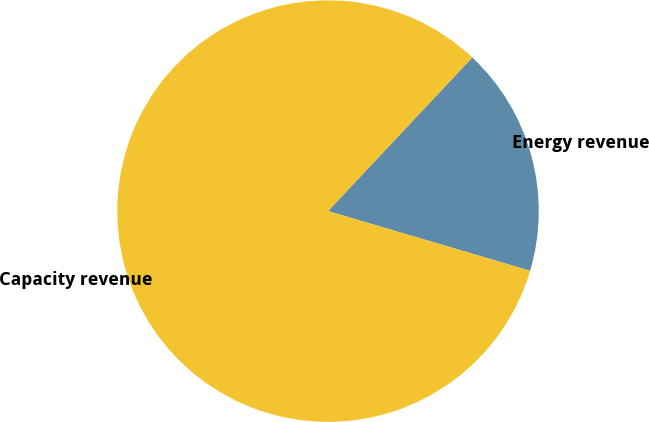Convert chart to OTSL. <chart><loc_0><loc_0><loc_500><loc_500><pie_chart><fcel>Energy revenue<fcel>Capacity revenue<nl><fcel>17.57%<fcel>82.43%<nl></chart> 